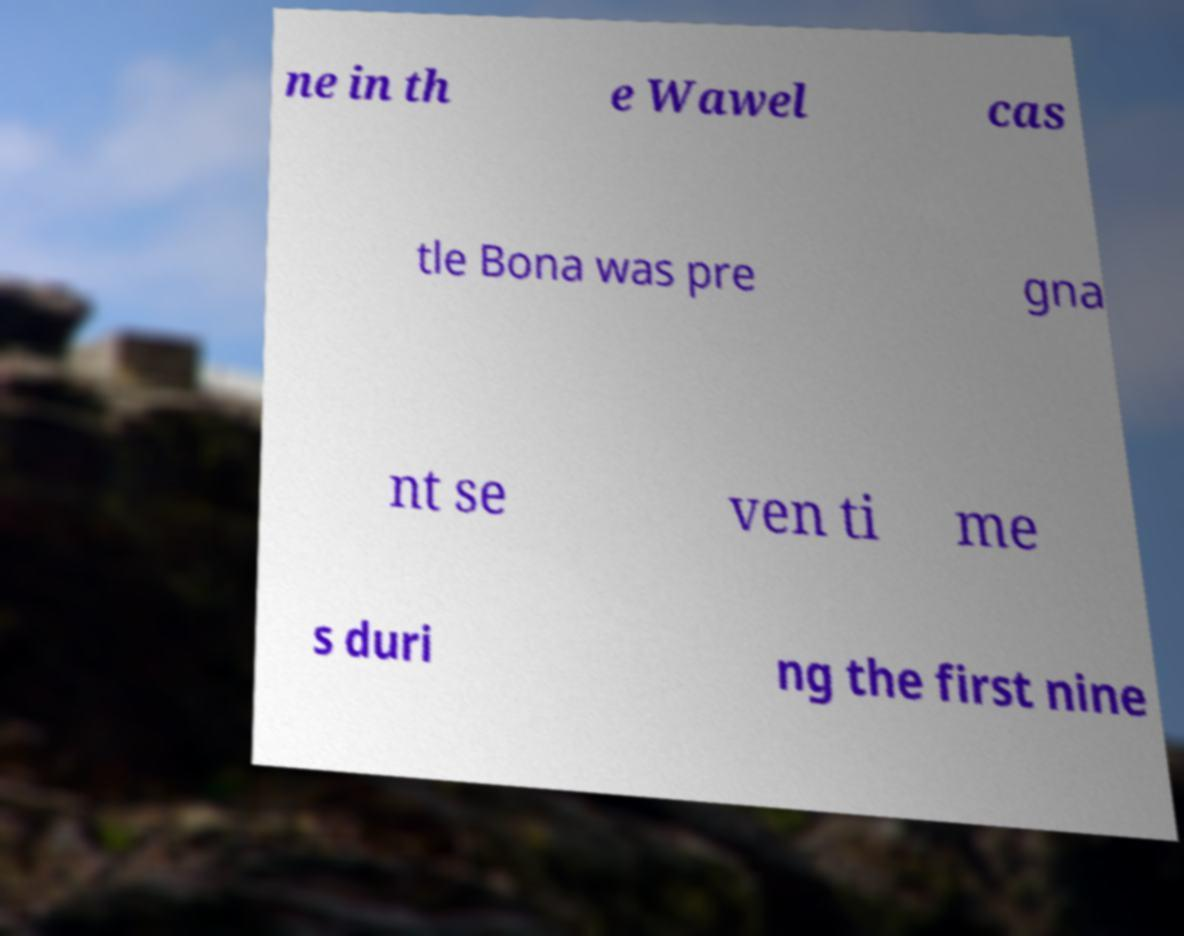Can you read and provide the text displayed in the image?This photo seems to have some interesting text. Can you extract and type it out for me? ne in th e Wawel cas tle Bona was pre gna nt se ven ti me s duri ng the first nine 